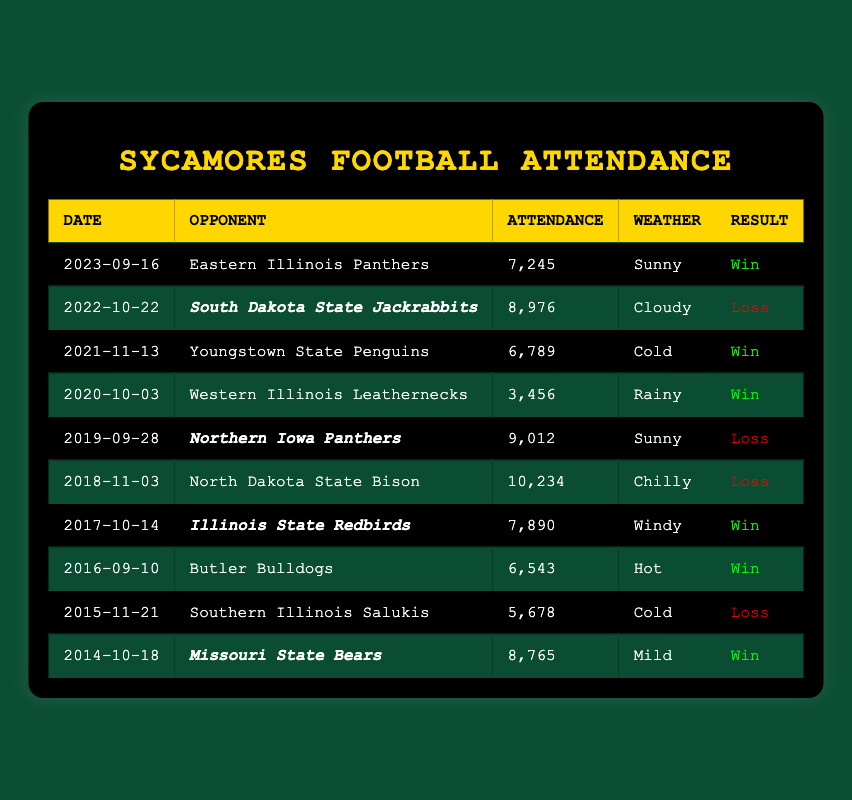What was the highest attendance recorded during a home game? The highest attendance can be found by looking through the attendance figures in the table. The highest figure is 10,234, from the game against North Dakota State Bison on November 3, 2018.
Answer: 10,234 What was the attendance for the most recent home game? The recent home game is listed at the top of the table, dated September 16, 2023, with an attendance of 7,245.
Answer: 7,245 How many homecoming games did the Sycamores play in the last decade? By checking the 'homecoming' column for any true values (marked or italicized in the table), we see that there were four homecoming games: against South Dakota State (2022), Northern Iowa (2019), Illinois State (2017), and Missouri State (2014).
Answer: 4 What was the win-loss ratio for the games listed? First, we tally the number of wins (5) and losses (5) by checking the results column. The win-loss ratio is calculated as 5 wins to 5 losses, leading to a ratio of 1:1.
Answer: 1:1 Did the Sycamores ever record a win in a homecoming game? By examining the results of the homecoming games identified before, Illinois State (2017) is the only homecoming game where the Sycamores recorded a win, while the other three were losses. Therefore, the answer is yes.
Answer: Yes What was the total attendance across all games? We sum the attendance for each game: 7,245 + 8,976 + 6,789 + 3,456 + 9,012 + 10,234 + 7,890 + 6,543 + 5,678 + 8,765 = 64,078. The total attendance is thus 64,078.
Answer: 64,078 How many games had an attendance greater than 8,000? By reviewing the attendance column, we count the games where attendance figures exceed 8,000: 8,976, 9,012, 10,234, and 8,765 correspond to four games total.
Answer: 4 What is the weather condition of the game with the highest attendance? The game with the highest attendance is on November 3, 2018. Looking under the 'weather' column for this row reveals that the weather condition was "Chilly".
Answer: Chilly 